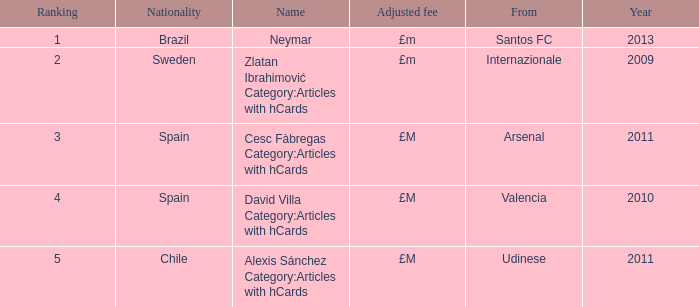Where is the ranked 2 players from? Internazionale. 